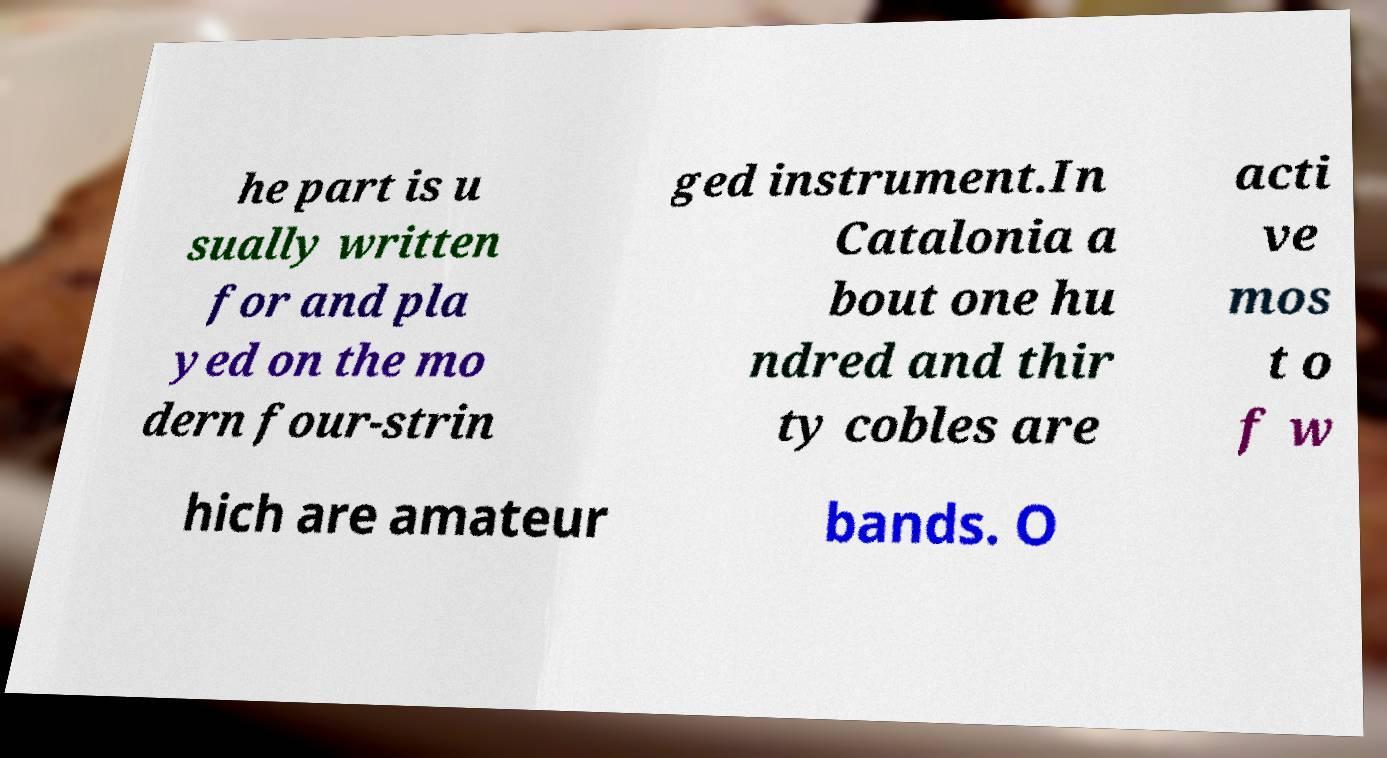Can you accurately transcribe the text from the provided image for me? he part is u sually written for and pla yed on the mo dern four-strin ged instrument.In Catalonia a bout one hu ndred and thir ty cobles are acti ve mos t o f w hich are amateur bands. O 